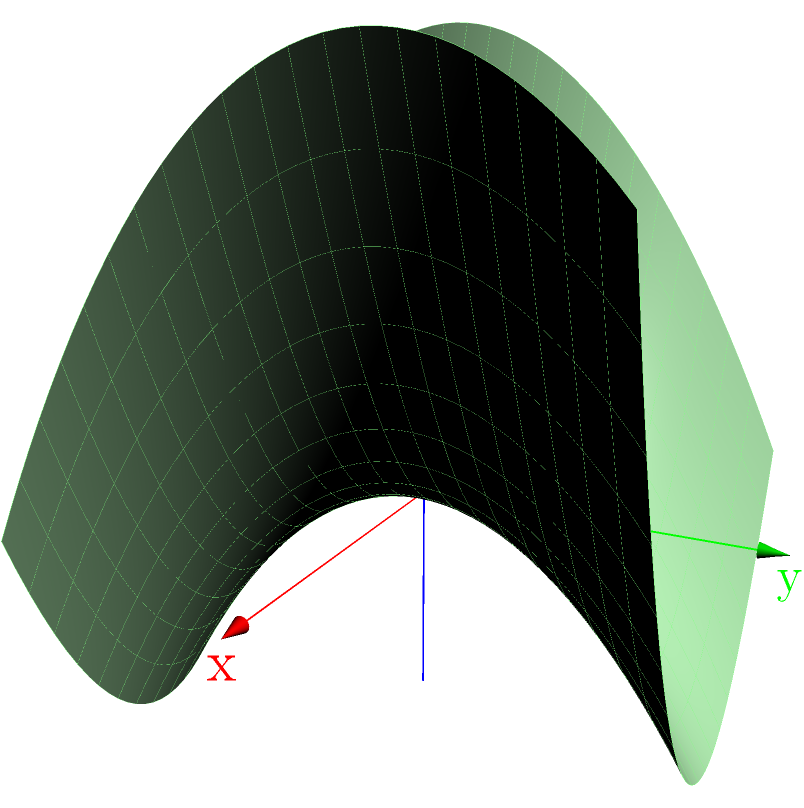In your VR terrain modeling application, you've created a 3D surface using a polynomial function. The surface is represented by the equation $z = 0.5x^2 - 0.3y^2 + 0.2xy$. What is the coefficient of the $xy$ term in this equation, and how does it affect the shape of the surface? To answer this question, let's break it down step-by-step:

1. The given equation is $z = 0.5x^2 - 0.3y^2 + 0.2xy$

2. In this polynomial, we have three terms:
   - $0.5x^2$: a quadratic term in x
   - $-0.3y^2$: a quadratic term in y
   - $0.2xy$: a mixed term with both x and y

3. The coefficient of the $xy$ term is 0.2

4. The effect of this term on the shape of the surface:
   - When the coefficient is positive (as it is here), it causes the surface to twist upwards in the first and third quadrants of the xy-plane, and downwards in the second and fourth quadrants.
   - The magnitude of the coefficient (0.2 in this case) determines how pronounced this twisting effect is.
   - If the coefficient were negative, the twisting would be in the opposite direction.
   - If the coefficient were zero, there would be no twisting, and the surface would be a simple paraboloid.

5. In the context of VR terrain modeling:
   - This term adds complexity to the terrain, creating saddle-like features.
   - It allows for more realistic and interesting landscapes, as real terrains often have complex curvatures that can't be modeled by simple quadratic terms alone.
Answer: 0.2; it causes twisting of the surface 